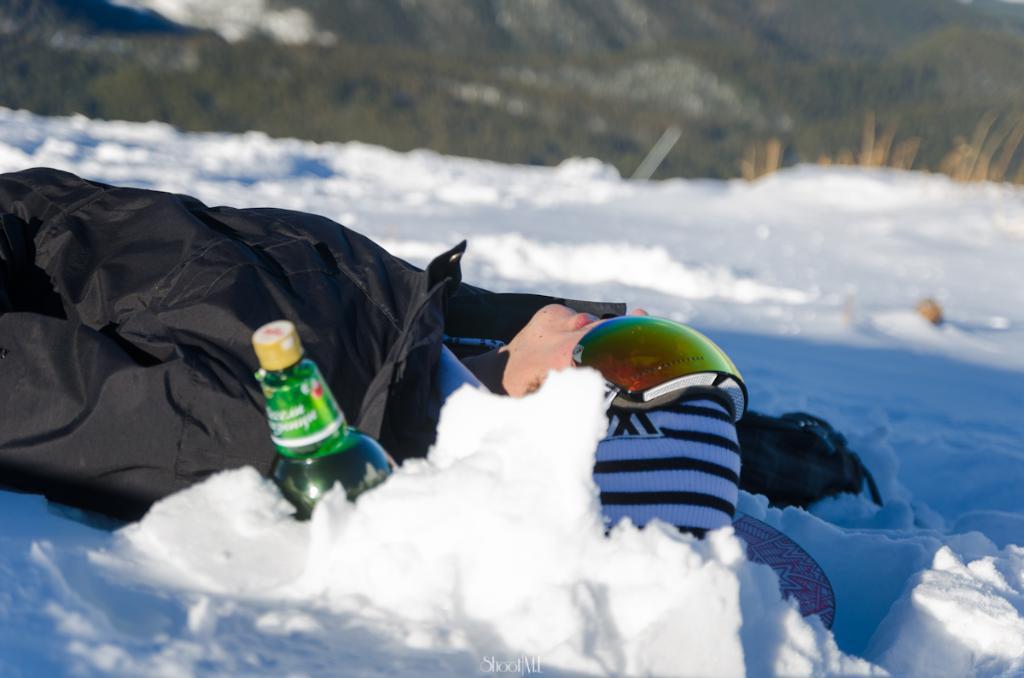Describe this image in one or two sentences. In this image there is a man lying on the ground. There is snow on the ground. In front of him there is a bottle. At the top there are plants. 